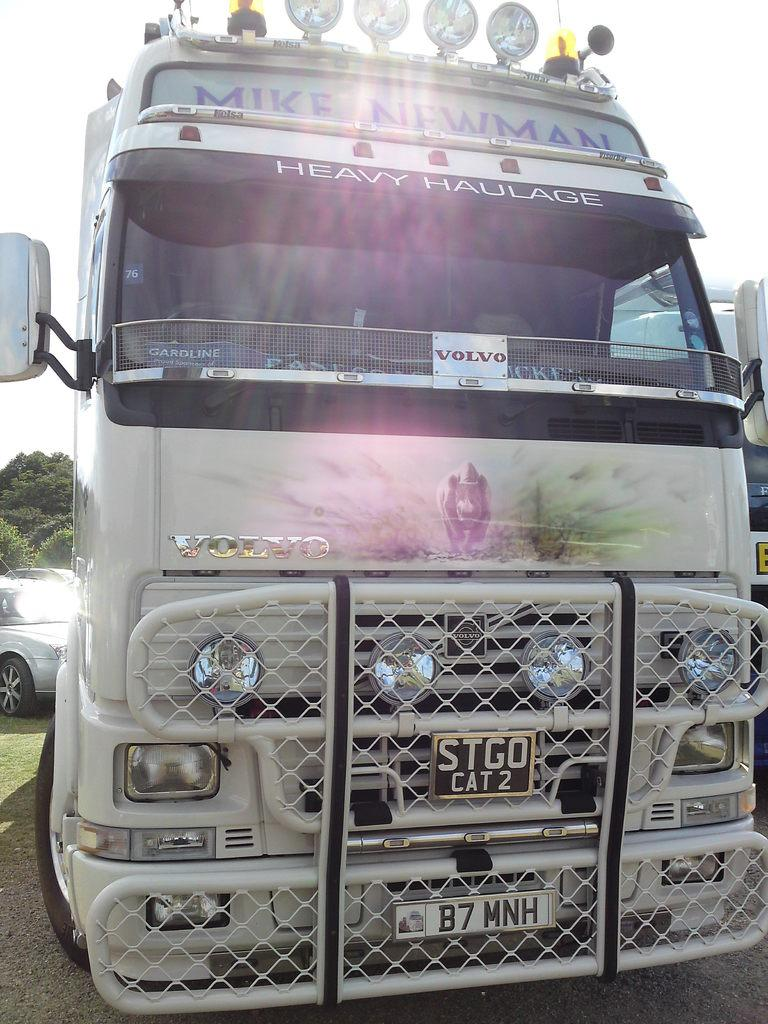<image>
Describe the image concisely. A Volvo bus says "Mike Newman" at the top in blue letters. 